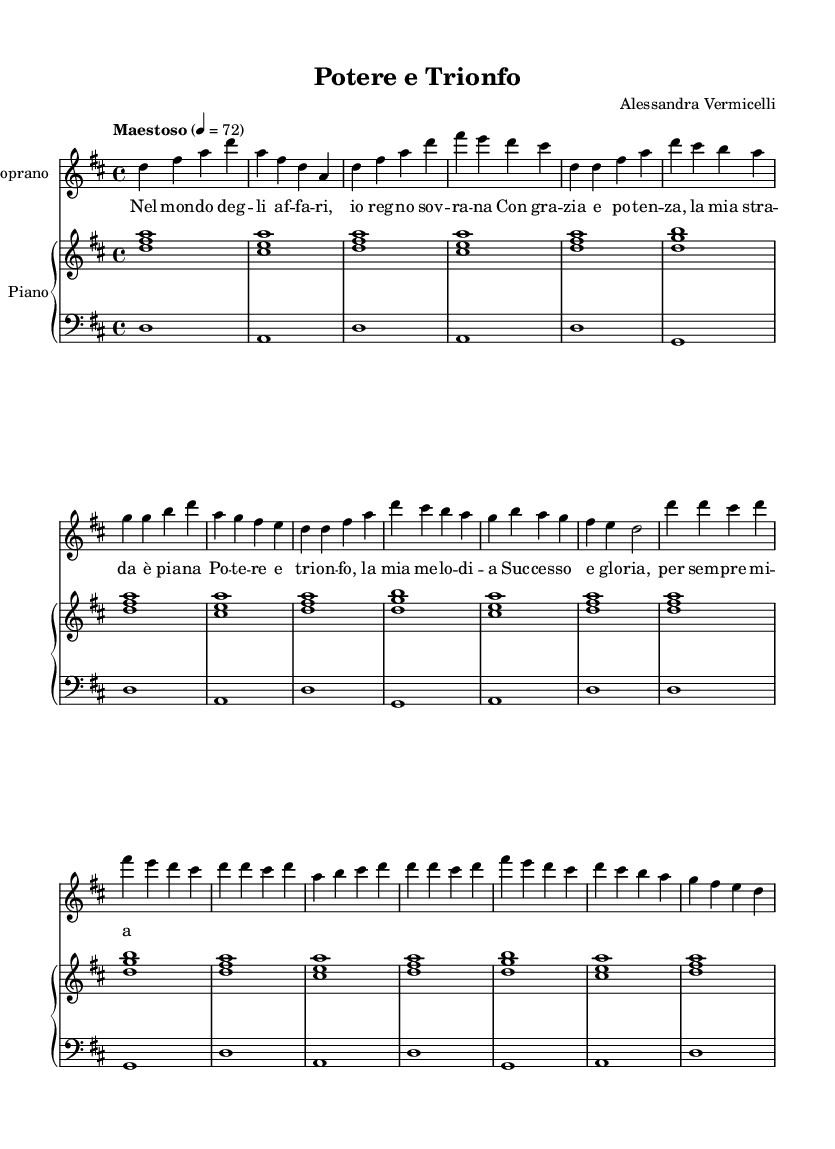What is the key signature of this music? The key signature is D major, which has two sharps: F# and C#.
Answer: D major What is the time signature of this music? The time signature is 4/4, indicating four beats per measure.
Answer: 4/4 What is the tempo marking for this piece? The tempo marking is "Maestoso," which indicates a stately and majestic tempo.
Answer: Maestoso How many measures are in the chorus section? The chorus section consists of 8 measures as counted from the music notation provided.
Answer: 8 measures What is the main theme expressed in the lyrics? The main theme revolves around power and triumph, reflecting a confident and victorious attitude.
Answer: Power and triumph Which voice is this score primarily written for? The score is primarily written for the soprano voice, indicated by the clef and vocal part.
Answer: Soprano How many different sections are present in this composition? The composition includes three distinct sections: Introduction, Verse 1, and Chorus.
Answer: Three sections 